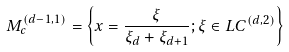<formula> <loc_0><loc_0><loc_500><loc_500>M _ { c } ^ { ( d - 1 , 1 ) } = \left \{ x = \frac { \xi } { \xi _ { d } + \xi _ { d + 1 } } ; \xi \in L C ^ { ( d , 2 ) } \right \}</formula> 